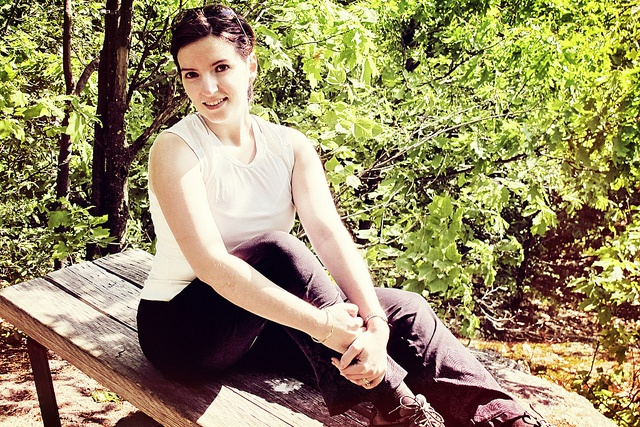Describe the objects in this image and their specific colors. I can see people in darkgreen, ivory, black, and tan tones and bench in darkgreen, beige, black, brown, and maroon tones in this image. 